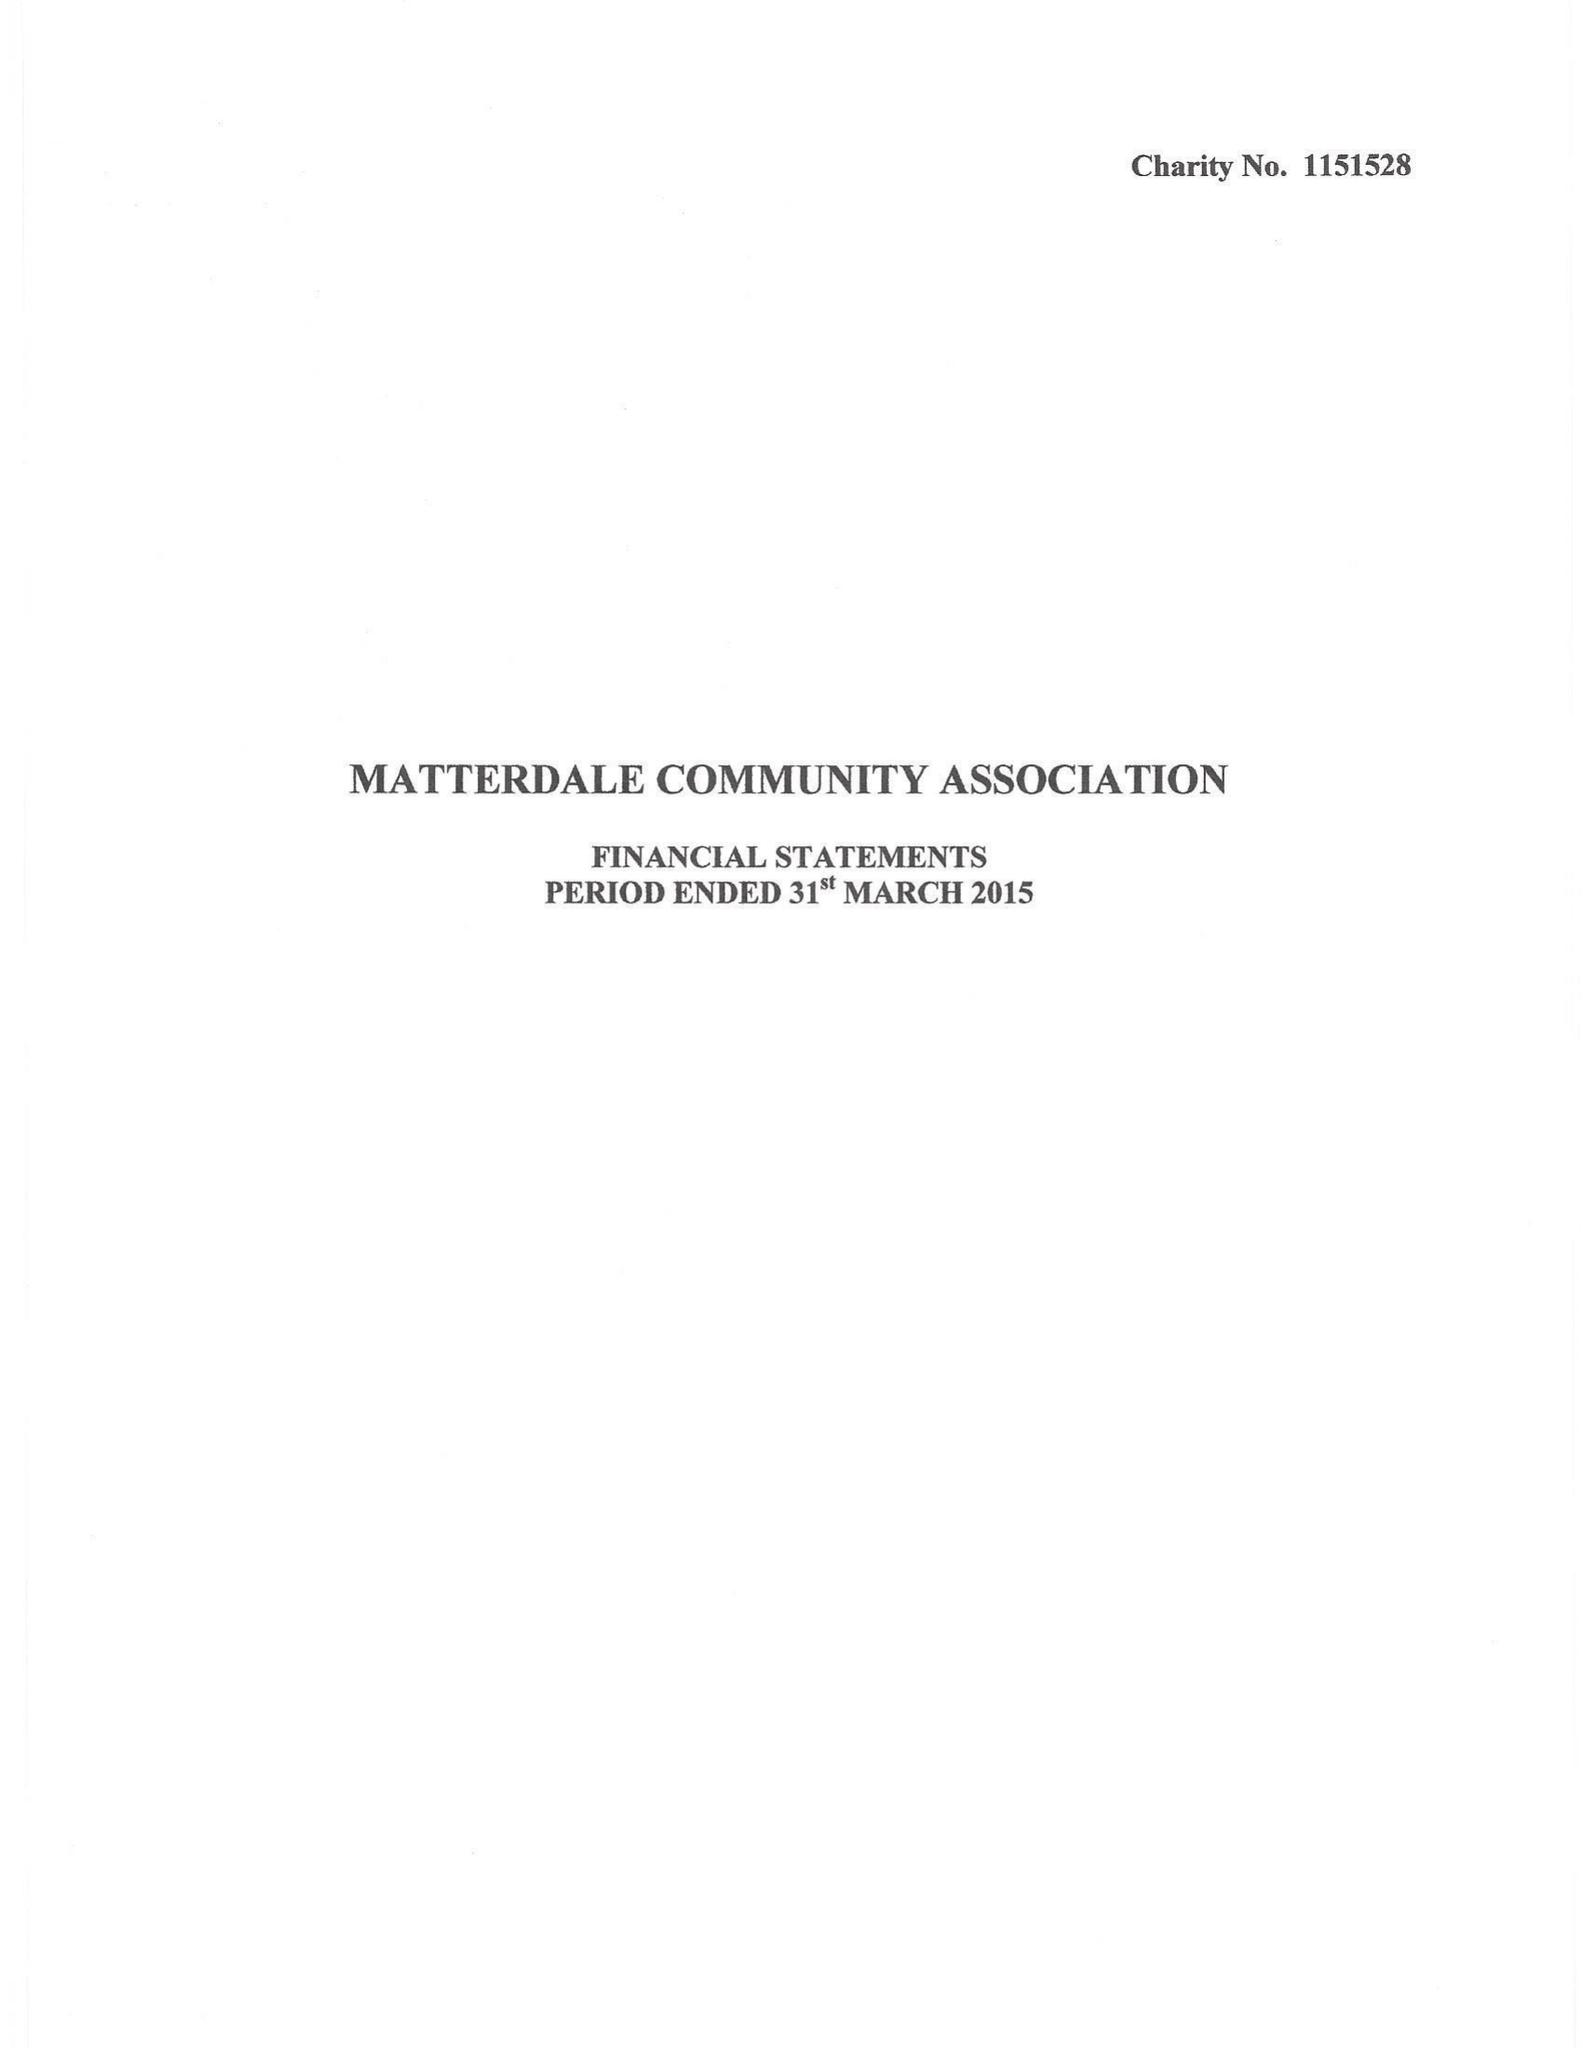What is the value for the report_date?
Answer the question using a single word or phrase. 2015-03-31 